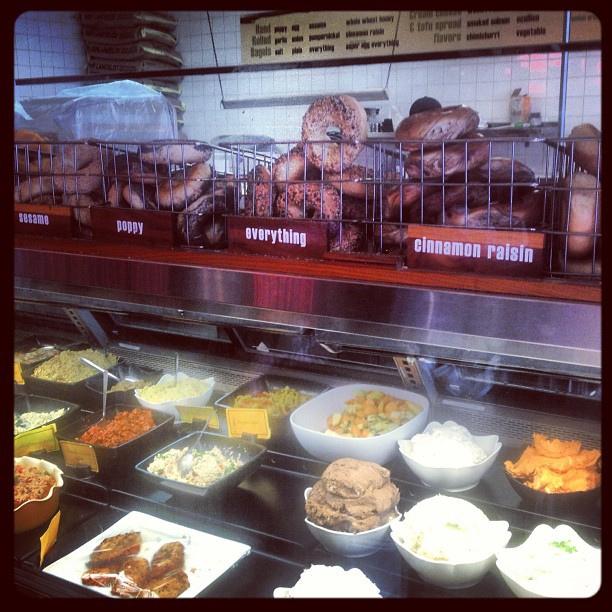What does the second sign from the left say?
Be succinct. Poppy. What cuisine is being showcased?
Write a very short answer. Chinese. What type of bagel is on the far right?
Quick response, please. Cinnamon raisin. Are there only bagels in the image?
Answer briefly. No. 